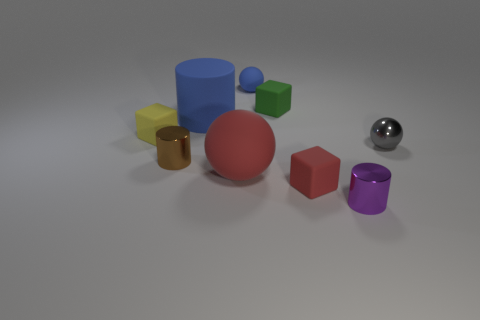If we were to categorize these objects by material, which ones could belong to the same category? Based on the visual characteristics of the objects, we could speculate that the large red ball and the small green cube might be categorized together as they both exhibit a matte texture. Conversely, the silver sphere appears to have a reflective surface, suggesting a different material category, potentially metal or a polished substance. 